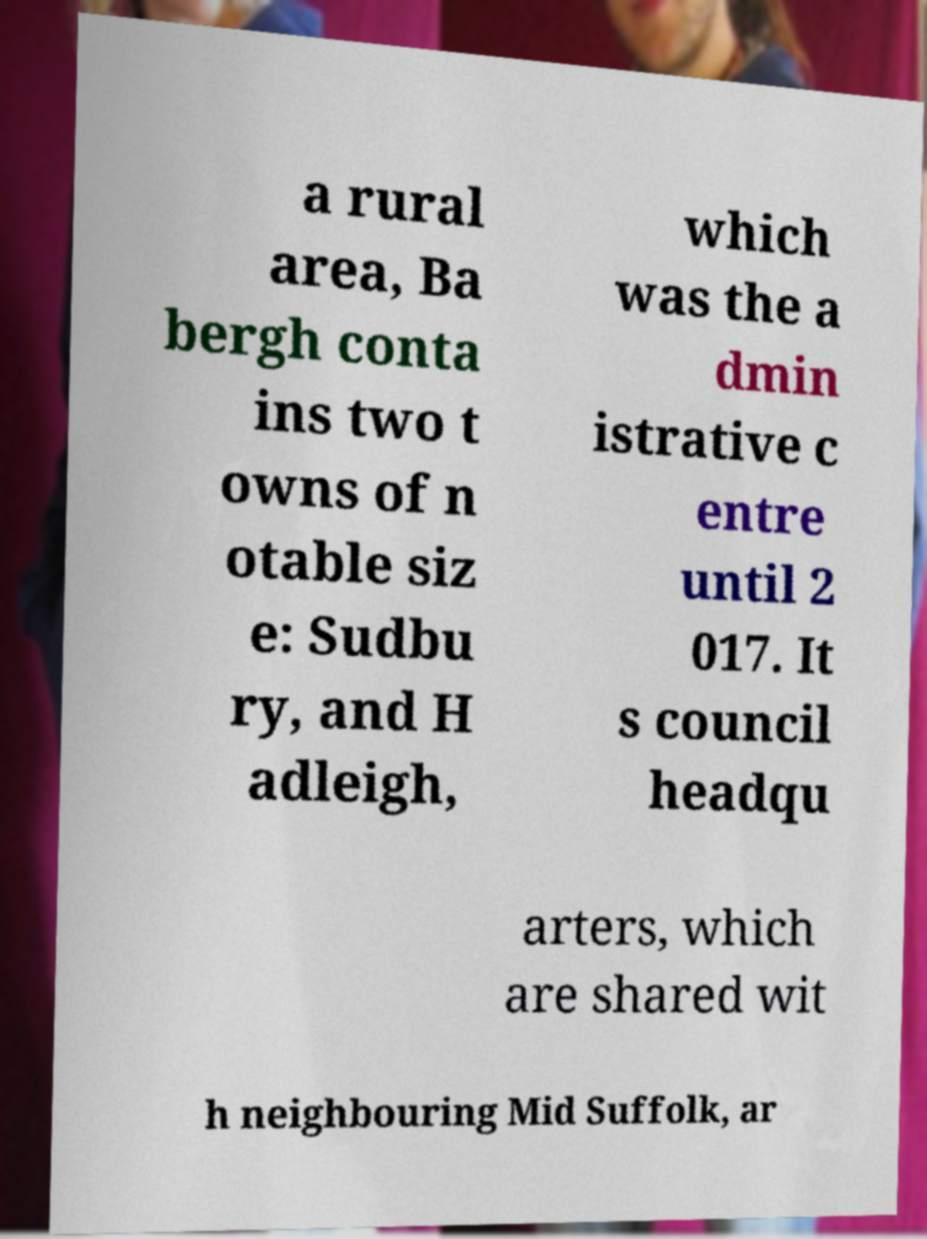Please read and relay the text visible in this image. What does it say? a rural area, Ba bergh conta ins two t owns of n otable siz e: Sudbu ry, and H adleigh, which was the a dmin istrative c entre until 2 017. It s council headqu arters, which are shared wit h neighbouring Mid Suffolk, ar 